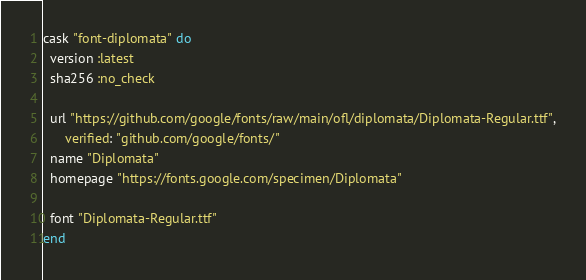<code> <loc_0><loc_0><loc_500><loc_500><_Ruby_>cask "font-diplomata" do
  version :latest
  sha256 :no_check

  url "https://github.com/google/fonts/raw/main/ofl/diplomata/Diplomata-Regular.ttf",
      verified: "github.com/google/fonts/"
  name "Diplomata"
  homepage "https://fonts.google.com/specimen/Diplomata"

  font "Diplomata-Regular.ttf"
end
</code> 